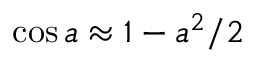Convert formula to latex. <formula><loc_0><loc_0><loc_500><loc_500>\cos a \approx 1 - a ^ { 2 } / 2</formula> 